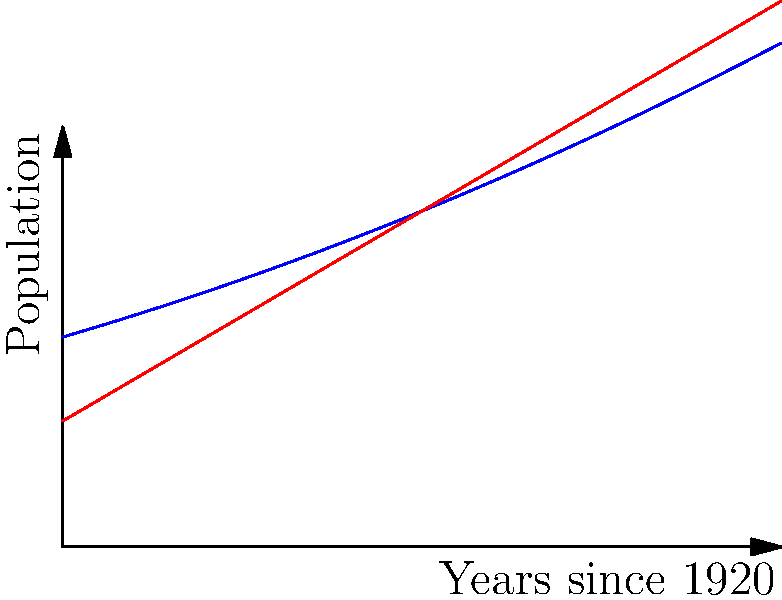The graph shows the population growth of Catholics and Protestants in Peoria from 1920 to 2020. The blue curve represents the Catholic population, given by $f(x) = 50000 + 500x + 2x^2$, and the red curve represents the Protestant population, given by $g(x) = 30000 + 1000x$, where $x$ is the number of years since 1920. Calculate the difference in total population growth between Catholics and Protestants over this 100-year period. To find the difference in total population growth, we need to:

1. Calculate the area between the two curves.
2. Set up the integral: $$\int_0^{100} [f(x) - g(x)] dx$$
3. Substitute the functions:
   $$\int_0^{100} [(50000 + 500x + 2x^2) - (30000 + 1000x)] dx$$
4. Simplify:
   $$\int_0^{100} [20000 - 500x + 2x^2] dx$$
5. Integrate:
   $$[20000x - 250x^2 + \frac{2}{3}x^3]_0^{100}$$
6. Evaluate the definite integral:
   $$(2000000 - 2500000 + 666666.67) - (0 - 0 + 0)$$
7. Calculate the final result:
   $$166666.67$$

This represents the difference in total population growth over the 100-year period.
Answer: 166,667 (rounded to nearest whole number) 